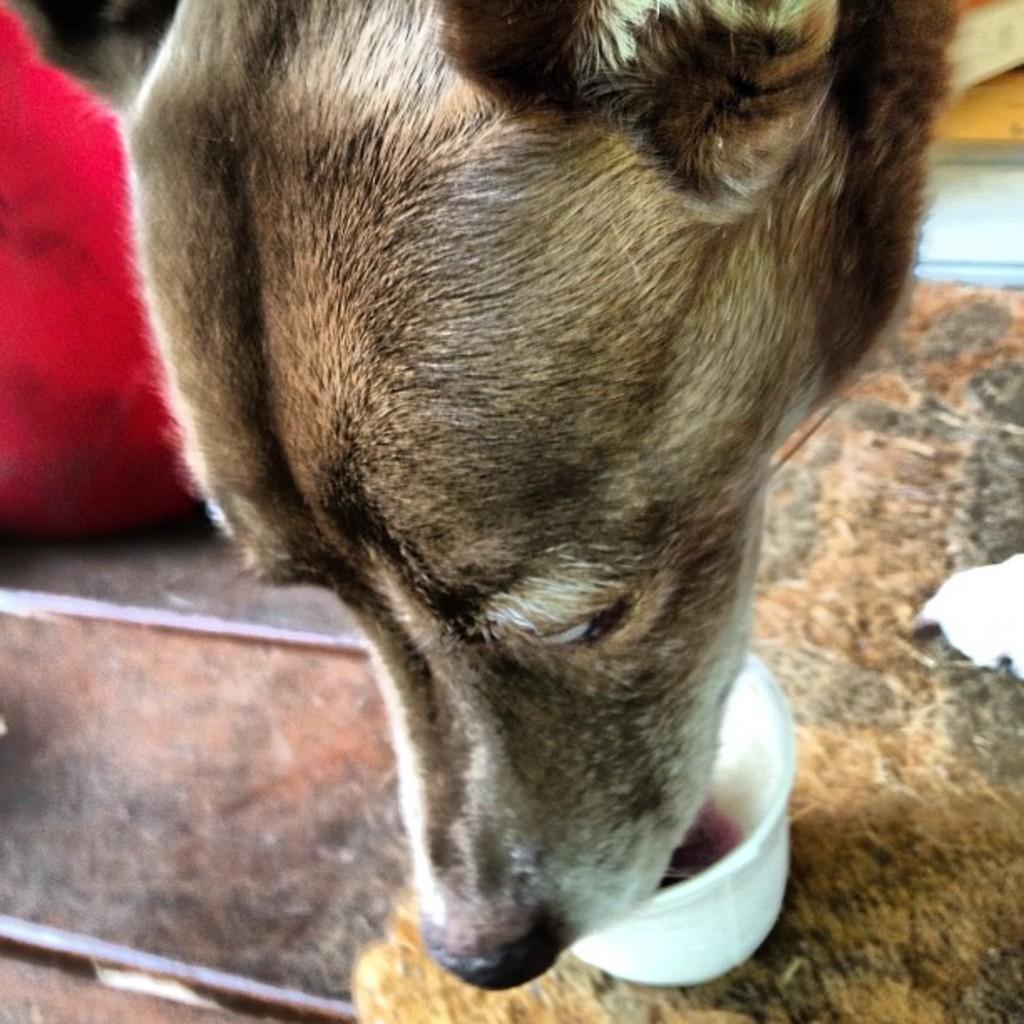Can you describe this image briefly? In this image I can see a dog eating some food which is placed in a bowl. On the left side, I can see a pink color cloth on the floor. 